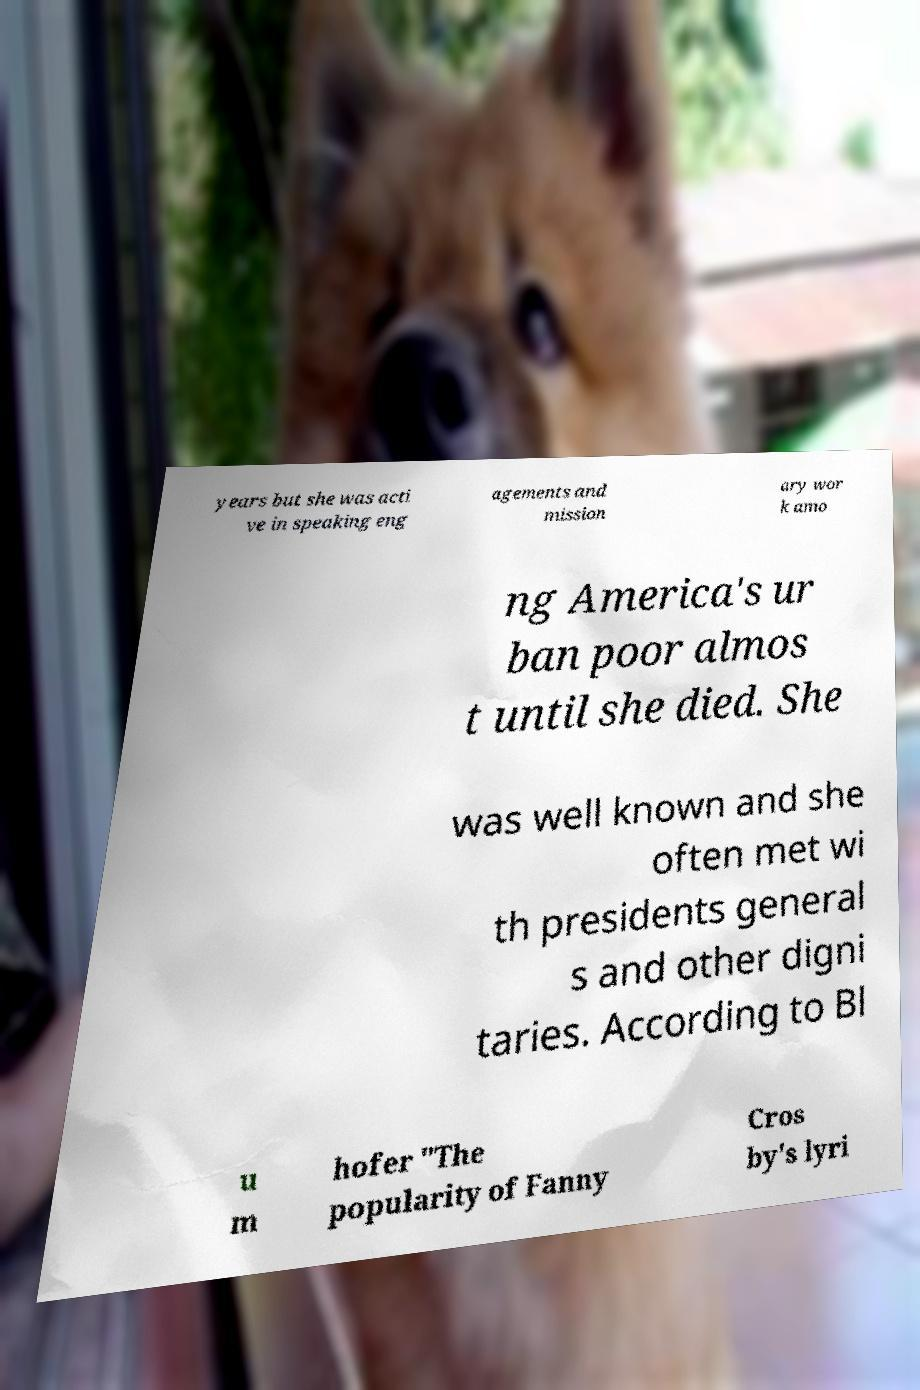For documentation purposes, I need the text within this image transcribed. Could you provide that? years but she was acti ve in speaking eng agements and mission ary wor k amo ng America's ur ban poor almos t until she died. She was well known and she often met wi th presidents general s and other digni taries. According to Bl u m hofer "The popularity of Fanny Cros by's lyri 